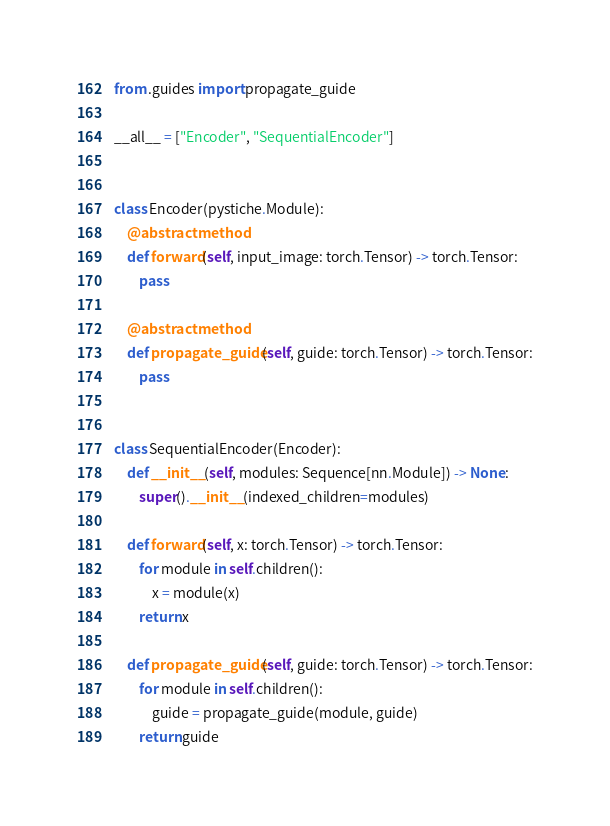<code> <loc_0><loc_0><loc_500><loc_500><_Python_>from .guides import propagate_guide

__all__ = ["Encoder", "SequentialEncoder"]


class Encoder(pystiche.Module):
    @abstractmethod
    def forward(self, input_image: torch.Tensor) -> torch.Tensor:
        pass

    @abstractmethod
    def propagate_guide(self, guide: torch.Tensor) -> torch.Tensor:
        pass


class SequentialEncoder(Encoder):
    def __init__(self, modules: Sequence[nn.Module]) -> None:
        super().__init__(indexed_children=modules)

    def forward(self, x: torch.Tensor) -> torch.Tensor:
        for module in self.children():
            x = module(x)
        return x

    def propagate_guide(self, guide: torch.Tensor) -> torch.Tensor:
        for module in self.children():
            guide = propagate_guide(module, guide)
        return guide
</code> 